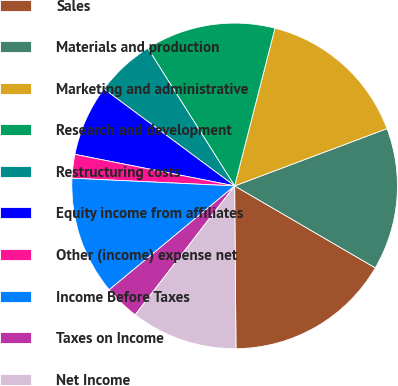Convert chart to OTSL. <chart><loc_0><loc_0><loc_500><loc_500><pie_chart><fcel>Sales<fcel>Materials and production<fcel>Marketing and administrative<fcel>Research and development<fcel>Restructuring costs<fcel>Equity income from affiliates<fcel>Other (income) expense net<fcel>Income Before Taxes<fcel>Taxes on Income<fcel>Net Income<nl><fcel>16.47%<fcel>14.12%<fcel>15.29%<fcel>12.94%<fcel>5.88%<fcel>7.06%<fcel>2.35%<fcel>11.76%<fcel>3.53%<fcel>10.59%<nl></chart> 